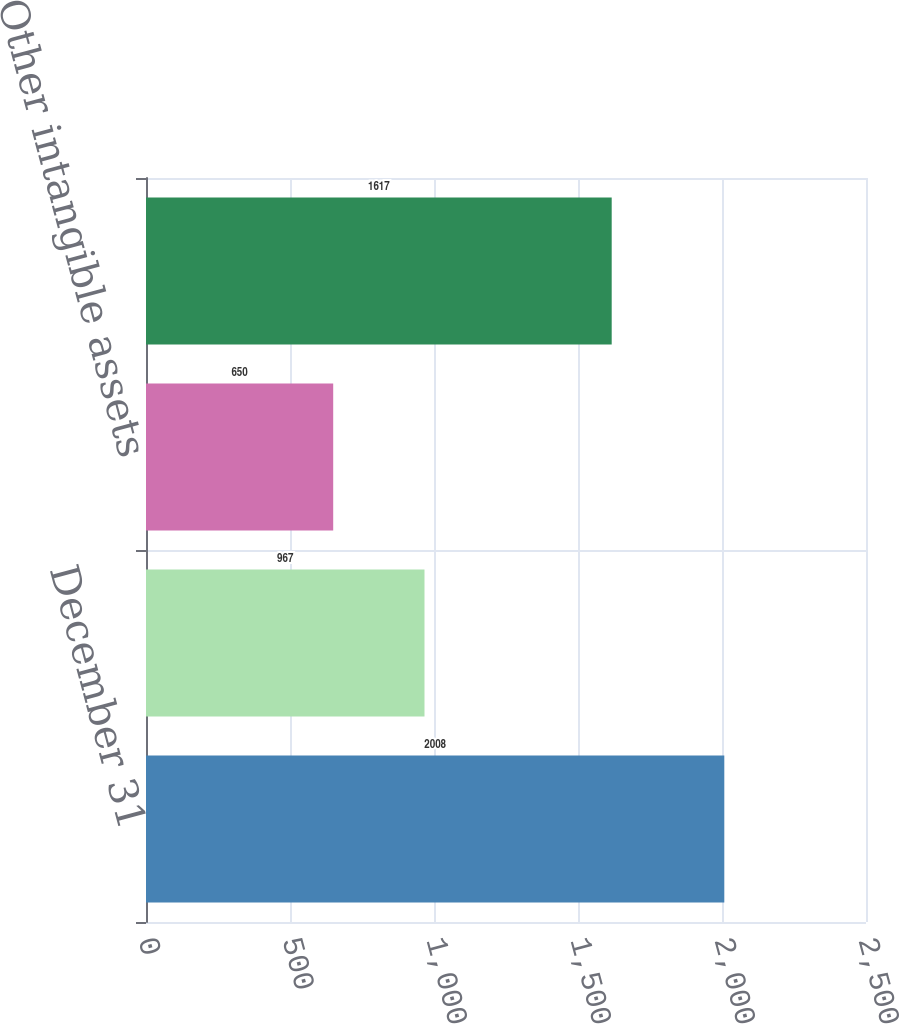<chart> <loc_0><loc_0><loc_500><loc_500><bar_chart><fcel>December 31<fcel>Contract and program<fcel>Other intangible assets<fcel>Total intangible assets<nl><fcel>2008<fcel>967<fcel>650<fcel>1617<nl></chart> 